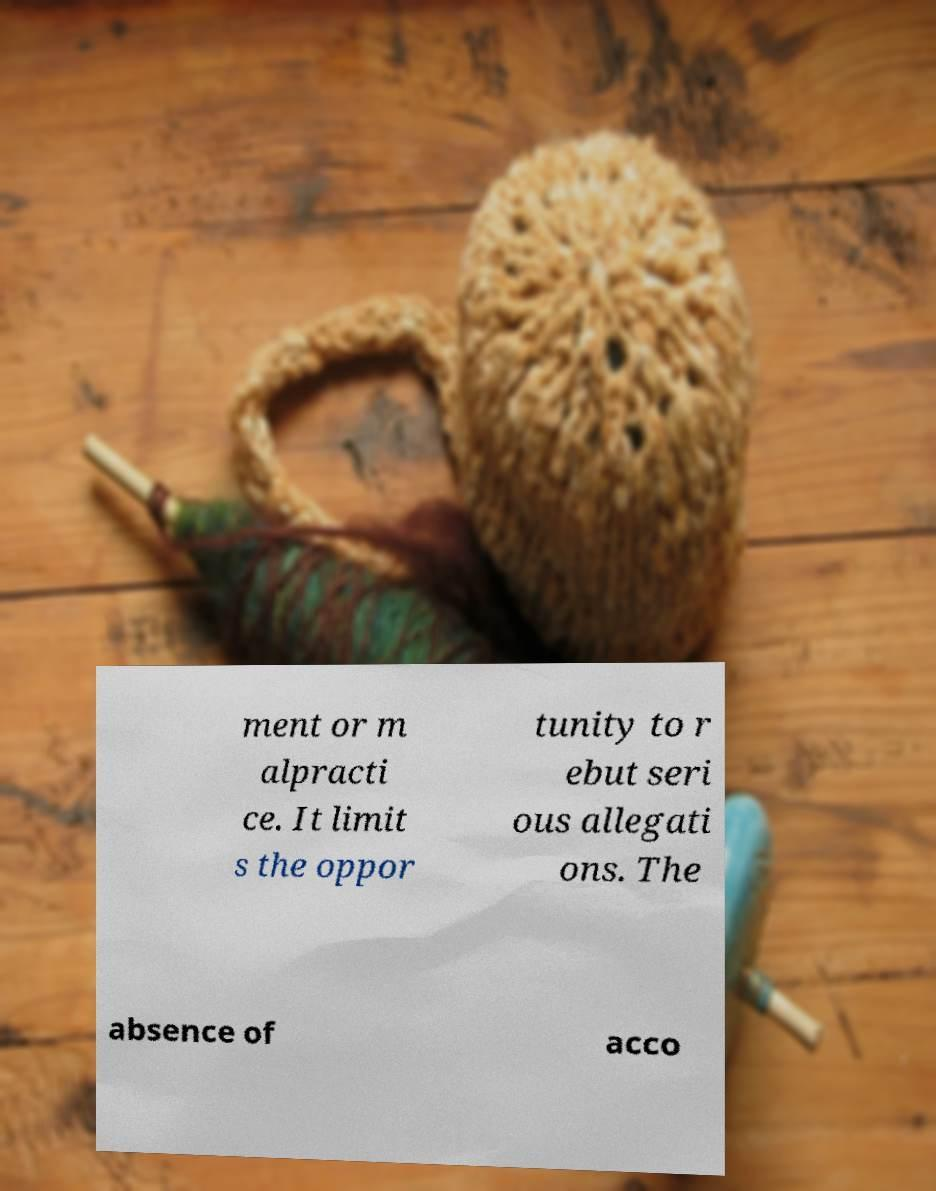Please identify and transcribe the text found in this image. ment or m alpracti ce. It limit s the oppor tunity to r ebut seri ous allegati ons. The absence of acco 